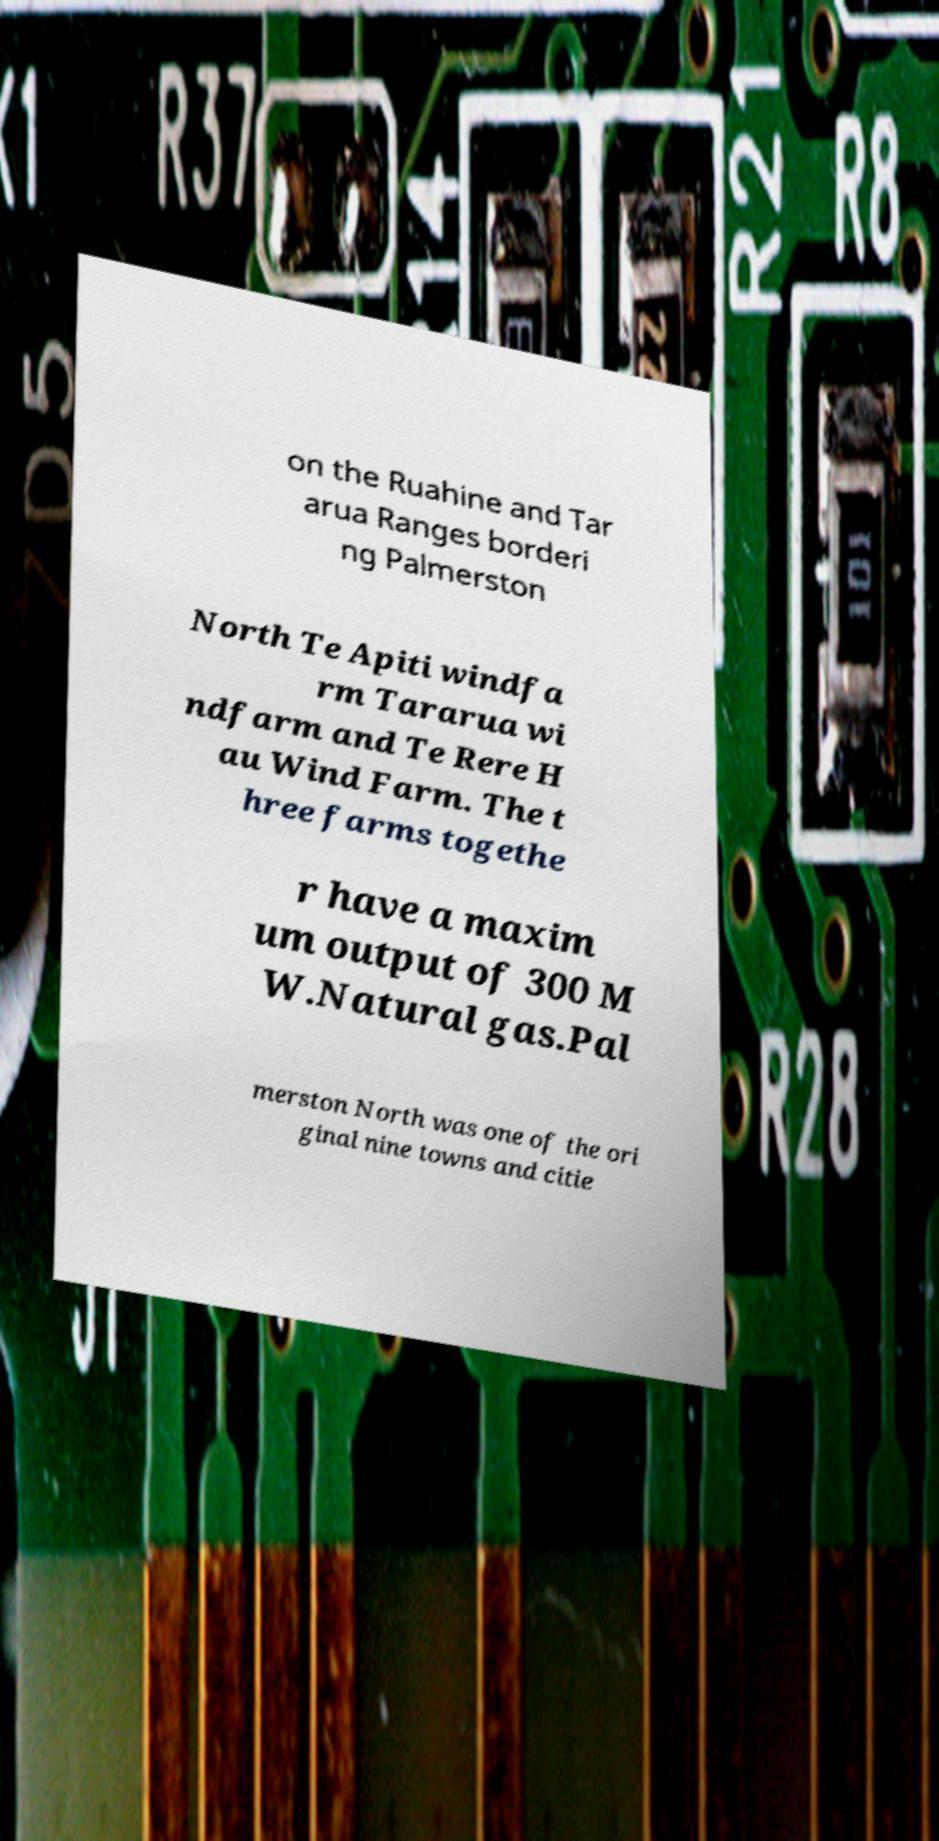Could you extract and type out the text from this image? on the Ruahine and Tar arua Ranges borderi ng Palmerston North Te Apiti windfa rm Tararua wi ndfarm and Te Rere H au Wind Farm. The t hree farms togethe r have a maxim um output of 300 M W.Natural gas.Pal merston North was one of the ori ginal nine towns and citie 